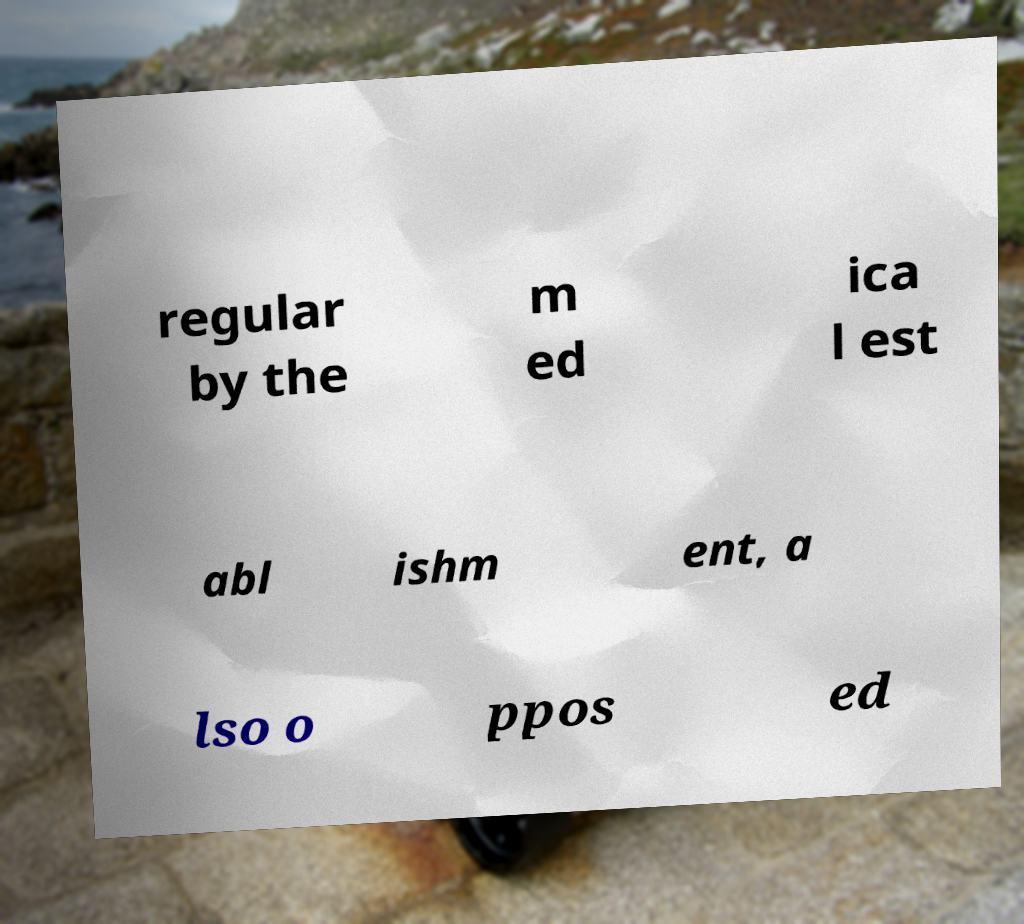Could you assist in decoding the text presented in this image and type it out clearly? regular by the m ed ica l est abl ishm ent, a lso o ppos ed 